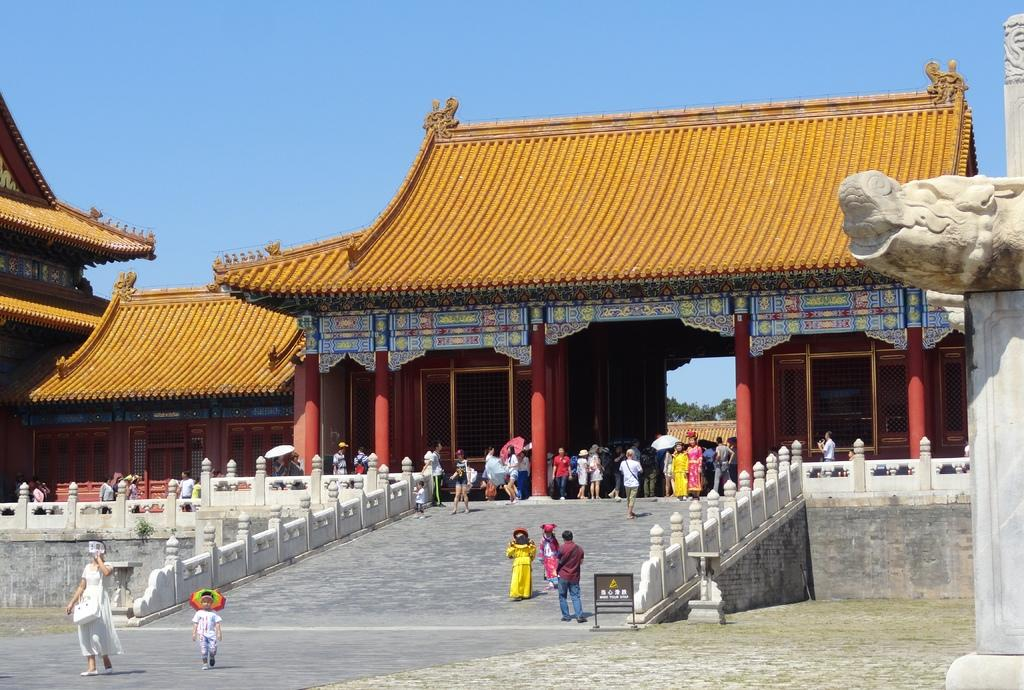What type of structures can be seen in the image? There are buildings in the image. What architectural features are present in the image? There are pillars in the image. What can be seen on the buildings in the image? There are windows in the image. Can you describe the people in the image? There is a group of people in the image, and some of them are holding umbrellas. What is the color of the sky in the image? The sky is blue in the image. What other elements can be seen in the image? There is a board and fencing in the image. Can you tell me how many trails are visible in the image? There are no trails present in the image. What type of rod is being used by the people in the image? There is no rod being used by the people in the image; some of them are holding umbrellas. 